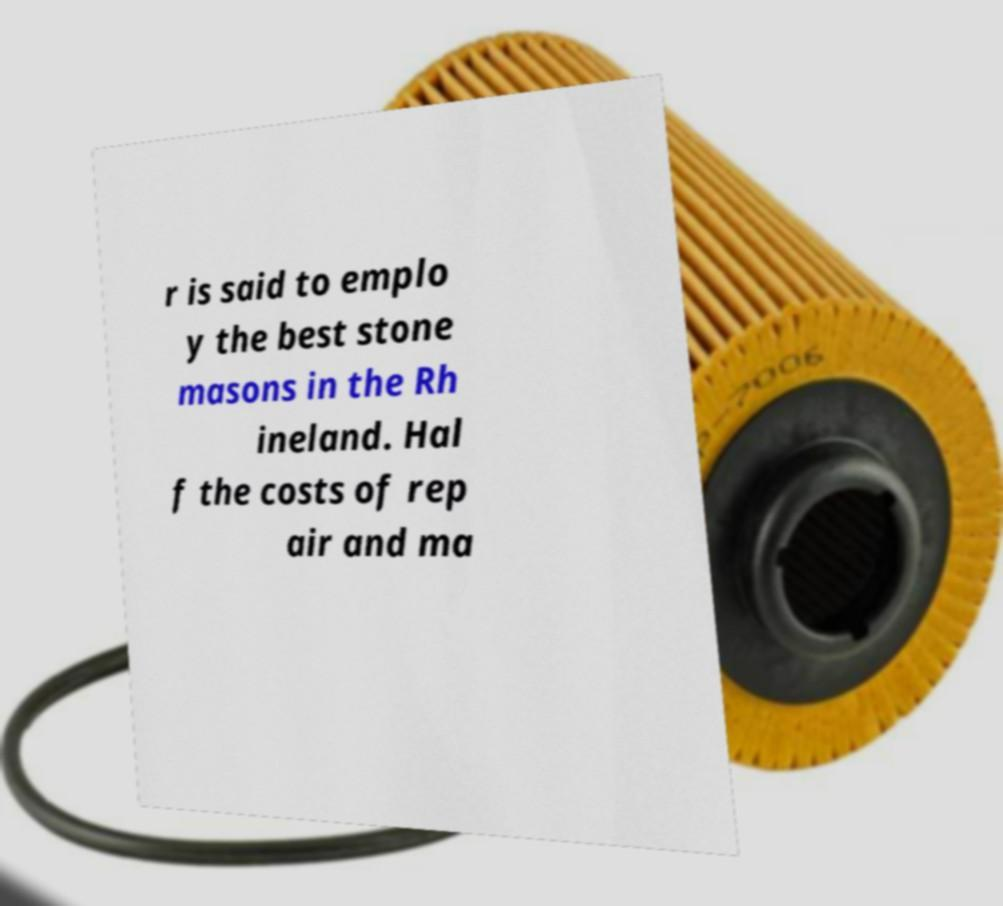Can you read and provide the text displayed in the image?This photo seems to have some interesting text. Can you extract and type it out for me? r is said to emplo y the best stone masons in the Rh ineland. Hal f the costs of rep air and ma 